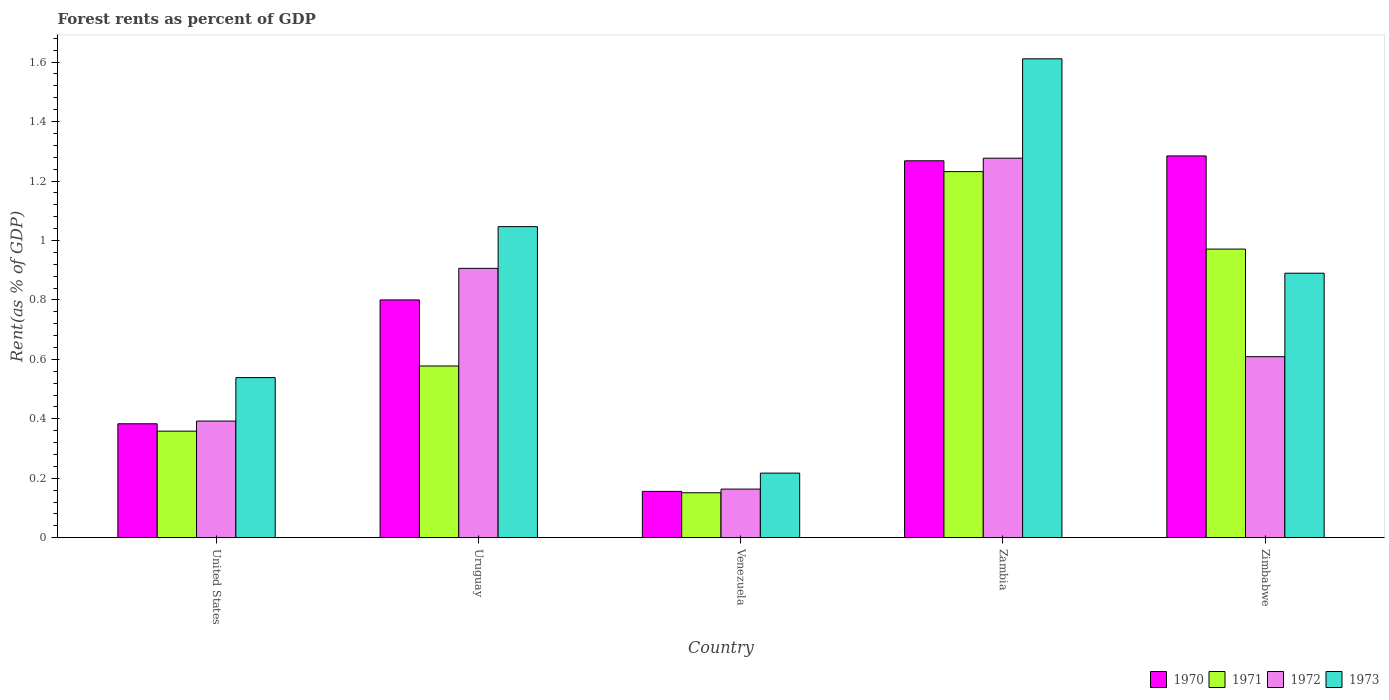How many different coloured bars are there?
Your response must be concise. 4. Are the number of bars per tick equal to the number of legend labels?
Your answer should be very brief. Yes. How many bars are there on the 5th tick from the left?
Keep it short and to the point. 4. What is the label of the 4th group of bars from the left?
Your response must be concise. Zambia. In how many cases, is the number of bars for a given country not equal to the number of legend labels?
Provide a succinct answer. 0. What is the forest rent in 1972 in Uruguay?
Make the answer very short. 0.91. Across all countries, what is the maximum forest rent in 1972?
Your response must be concise. 1.28. Across all countries, what is the minimum forest rent in 1971?
Provide a succinct answer. 0.15. In which country was the forest rent in 1970 maximum?
Ensure brevity in your answer.  Zimbabwe. In which country was the forest rent in 1970 minimum?
Provide a short and direct response. Venezuela. What is the total forest rent in 1971 in the graph?
Make the answer very short. 3.29. What is the difference between the forest rent in 1971 in Uruguay and that in Zimbabwe?
Make the answer very short. -0.39. What is the difference between the forest rent in 1972 in Zimbabwe and the forest rent in 1971 in Zambia?
Keep it short and to the point. -0.62. What is the average forest rent in 1972 per country?
Your answer should be compact. 0.67. What is the difference between the forest rent of/in 1970 and forest rent of/in 1972 in Zambia?
Offer a terse response. -0.01. What is the ratio of the forest rent in 1970 in United States to that in Uruguay?
Your answer should be compact. 0.48. What is the difference between the highest and the second highest forest rent in 1972?
Your answer should be very brief. -0.37. What is the difference between the highest and the lowest forest rent in 1971?
Keep it short and to the point. 1.08. In how many countries, is the forest rent in 1971 greater than the average forest rent in 1971 taken over all countries?
Keep it short and to the point. 2. Is the sum of the forest rent in 1973 in United States and Zimbabwe greater than the maximum forest rent in 1971 across all countries?
Your answer should be very brief. Yes. Is it the case that in every country, the sum of the forest rent in 1971 and forest rent in 1973 is greater than the sum of forest rent in 1970 and forest rent in 1972?
Provide a short and direct response. No. What does the 2nd bar from the right in Zimbabwe represents?
Make the answer very short. 1972. Where does the legend appear in the graph?
Ensure brevity in your answer.  Bottom right. How many legend labels are there?
Keep it short and to the point. 4. How are the legend labels stacked?
Provide a short and direct response. Horizontal. What is the title of the graph?
Offer a terse response. Forest rents as percent of GDP. Does "2009" appear as one of the legend labels in the graph?
Provide a succinct answer. No. What is the label or title of the X-axis?
Give a very brief answer. Country. What is the label or title of the Y-axis?
Your answer should be compact. Rent(as % of GDP). What is the Rent(as % of GDP) in 1970 in United States?
Keep it short and to the point. 0.38. What is the Rent(as % of GDP) in 1971 in United States?
Offer a terse response. 0.36. What is the Rent(as % of GDP) in 1972 in United States?
Ensure brevity in your answer.  0.39. What is the Rent(as % of GDP) in 1973 in United States?
Keep it short and to the point. 0.54. What is the Rent(as % of GDP) in 1970 in Uruguay?
Offer a very short reply. 0.8. What is the Rent(as % of GDP) in 1971 in Uruguay?
Your answer should be compact. 0.58. What is the Rent(as % of GDP) in 1972 in Uruguay?
Keep it short and to the point. 0.91. What is the Rent(as % of GDP) of 1973 in Uruguay?
Your answer should be compact. 1.05. What is the Rent(as % of GDP) in 1970 in Venezuela?
Provide a succinct answer. 0.16. What is the Rent(as % of GDP) of 1971 in Venezuela?
Provide a succinct answer. 0.15. What is the Rent(as % of GDP) in 1972 in Venezuela?
Your answer should be very brief. 0.16. What is the Rent(as % of GDP) in 1973 in Venezuela?
Keep it short and to the point. 0.22. What is the Rent(as % of GDP) in 1970 in Zambia?
Offer a very short reply. 1.27. What is the Rent(as % of GDP) of 1971 in Zambia?
Ensure brevity in your answer.  1.23. What is the Rent(as % of GDP) in 1972 in Zambia?
Make the answer very short. 1.28. What is the Rent(as % of GDP) of 1973 in Zambia?
Your answer should be compact. 1.61. What is the Rent(as % of GDP) in 1970 in Zimbabwe?
Offer a very short reply. 1.28. What is the Rent(as % of GDP) in 1971 in Zimbabwe?
Give a very brief answer. 0.97. What is the Rent(as % of GDP) of 1972 in Zimbabwe?
Your answer should be compact. 0.61. What is the Rent(as % of GDP) in 1973 in Zimbabwe?
Provide a short and direct response. 0.89. Across all countries, what is the maximum Rent(as % of GDP) of 1970?
Give a very brief answer. 1.28. Across all countries, what is the maximum Rent(as % of GDP) in 1971?
Your response must be concise. 1.23. Across all countries, what is the maximum Rent(as % of GDP) of 1972?
Offer a very short reply. 1.28. Across all countries, what is the maximum Rent(as % of GDP) of 1973?
Keep it short and to the point. 1.61. Across all countries, what is the minimum Rent(as % of GDP) of 1970?
Your answer should be very brief. 0.16. Across all countries, what is the minimum Rent(as % of GDP) in 1971?
Provide a short and direct response. 0.15. Across all countries, what is the minimum Rent(as % of GDP) of 1972?
Make the answer very short. 0.16. Across all countries, what is the minimum Rent(as % of GDP) of 1973?
Your response must be concise. 0.22. What is the total Rent(as % of GDP) of 1970 in the graph?
Your answer should be compact. 3.89. What is the total Rent(as % of GDP) in 1971 in the graph?
Your response must be concise. 3.29. What is the total Rent(as % of GDP) of 1972 in the graph?
Provide a succinct answer. 3.35. What is the total Rent(as % of GDP) of 1973 in the graph?
Your answer should be very brief. 4.3. What is the difference between the Rent(as % of GDP) in 1970 in United States and that in Uruguay?
Offer a terse response. -0.42. What is the difference between the Rent(as % of GDP) of 1971 in United States and that in Uruguay?
Your answer should be compact. -0.22. What is the difference between the Rent(as % of GDP) of 1972 in United States and that in Uruguay?
Make the answer very short. -0.51. What is the difference between the Rent(as % of GDP) of 1973 in United States and that in Uruguay?
Offer a very short reply. -0.51. What is the difference between the Rent(as % of GDP) of 1970 in United States and that in Venezuela?
Your response must be concise. 0.23. What is the difference between the Rent(as % of GDP) of 1971 in United States and that in Venezuela?
Offer a terse response. 0.21. What is the difference between the Rent(as % of GDP) in 1972 in United States and that in Venezuela?
Provide a succinct answer. 0.23. What is the difference between the Rent(as % of GDP) of 1973 in United States and that in Venezuela?
Keep it short and to the point. 0.32. What is the difference between the Rent(as % of GDP) of 1970 in United States and that in Zambia?
Make the answer very short. -0.88. What is the difference between the Rent(as % of GDP) in 1971 in United States and that in Zambia?
Your response must be concise. -0.87. What is the difference between the Rent(as % of GDP) in 1972 in United States and that in Zambia?
Give a very brief answer. -0.88. What is the difference between the Rent(as % of GDP) in 1973 in United States and that in Zambia?
Ensure brevity in your answer.  -1.07. What is the difference between the Rent(as % of GDP) of 1970 in United States and that in Zimbabwe?
Offer a terse response. -0.9. What is the difference between the Rent(as % of GDP) in 1971 in United States and that in Zimbabwe?
Give a very brief answer. -0.61. What is the difference between the Rent(as % of GDP) of 1972 in United States and that in Zimbabwe?
Provide a succinct answer. -0.22. What is the difference between the Rent(as % of GDP) in 1973 in United States and that in Zimbabwe?
Your response must be concise. -0.35. What is the difference between the Rent(as % of GDP) in 1970 in Uruguay and that in Venezuela?
Your response must be concise. 0.64. What is the difference between the Rent(as % of GDP) in 1971 in Uruguay and that in Venezuela?
Make the answer very short. 0.43. What is the difference between the Rent(as % of GDP) of 1972 in Uruguay and that in Venezuela?
Offer a very short reply. 0.74. What is the difference between the Rent(as % of GDP) in 1973 in Uruguay and that in Venezuela?
Offer a very short reply. 0.83. What is the difference between the Rent(as % of GDP) of 1970 in Uruguay and that in Zambia?
Your response must be concise. -0.47. What is the difference between the Rent(as % of GDP) of 1971 in Uruguay and that in Zambia?
Keep it short and to the point. -0.65. What is the difference between the Rent(as % of GDP) of 1972 in Uruguay and that in Zambia?
Give a very brief answer. -0.37. What is the difference between the Rent(as % of GDP) in 1973 in Uruguay and that in Zambia?
Your answer should be very brief. -0.56. What is the difference between the Rent(as % of GDP) of 1970 in Uruguay and that in Zimbabwe?
Keep it short and to the point. -0.48. What is the difference between the Rent(as % of GDP) of 1971 in Uruguay and that in Zimbabwe?
Keep it short and to the point. -0.39. What is the difference between the Rent(as % of GDP) of 1972 in Uruguay and that in Zimbabwe?
Provide a short and direct response. 0.3. What is the difference between the Rent(as % of GDP) of 1973 in Uruguay and that in Zimbabwe?
Ensure brevity in your answer.  0.16. What is the difference between the Rent(as % of GDP) in 1970 in Venezuela and that in Zambia?
Offer a terse response. -1.11. What is the difference between the Rent(as % of GDP) of 1971 in Venezuela and that in Zambia?
Offer a terse response. -1.08. What is the difference between the Rent(as % of GDP) in 1972 in Venezuela and that in Zambia?
Provide a short and direct response. -1.11. What is the difference between the Rent(as % of GDP) of 1973 in Venezuela and that in Zambia?
Your answer should be compact. -1.39. What is the difference between the Rent(as % of GDP) in 1970 in Venezuela and that in Zimbabwe?
Provide a succinct answer. -1.13. What is the difference between the Rent(as % of GDP) in 1971 in Venezuela and that in Zimbabwe?
Give a very brief answer. -0.82. What is the difference between the Rent(as % of GDP) in 1972 in Venezuela and that in Zimbabwe?
Offer a very short reply. -0.45. What is the difference between the Rent(as % of GDP) in 1973 in Venezuela and that in Zimbabwe?
Ensure brevity in your answer.  -0.67. What is the difference between the Rent(as % of GDP) in 1970 in Zambia and that in Zimbabwe?
Ensure brevity in your answer.  -0.02. What is the difference between the Rent(as % of GDP) of 1971 in Zambia and that in Zimbabwe?
Your answer should be very brief. 0.26. What is the difference between the Rent(as % of GDP) of 1972 in Zambia and that in Zimbabwe?
Provide a short and direct response. 0.67. What is the difference between the Rent(as % of GDP) in 1973 in Zambia and that in Zimbabwe?
Your response must be concise. 0.72. What is the difference between the Rent(as % of GDP) in 1970 in United States and the Rent(as % of GDP) in 1971 in Uruguay?
Offer a terse response. -0.19. What is the difference between the Rent(as % of GDP) in 1970 in United States and the Rent(as % of GDP) in 1972 in Uruguay?
Your answer should be very brief. -0.52. What is the difference between the Rent(as % of GDP) in 1970 in United States and the Rent(as % of GDP) in 1973 in Uruguay?
Give a very brief answer. -0.66. What is the difference between the Rent(as % of GDP) in 1971 in United States and the Rent(as % of GDP) in 1972 in Uruguay?
Provide a short and direct response. -0.55. What is the difference between the Rent(as % of GDP) in 1971 in United States and the Rent(as % of GDP) in 1973 in Uruguay?
Ensure brevity in your answer.  -0.69. What is the difference between the Rent(as % of GDP) of 1972 in United States and the Rent(as % of GDP) of 1973 in Uruguay?
Offer a terse response. -0.65. What is the difference between the Rent(as % of GDP) in 1970 in United States and the Rent(as % of GDP) in 1971 in Venezuela?
Ensure brevity in your answer.  0.23. What is the difference between the Rent(as % of GDP) in 1970 in United States and the Rent(as % of GDP) in 1972 in Venezuela?
Your answer should be compact. 0.22. What is the difference between the Rent(as % of GDP) in 1970 in United States and the Rent(as % of GDP) in 1973 in Venezuela?
Provide a succinct answer. 0.17. What is the difference between the Rent(as % of GDP) of 1971 in United States and the Rent(as % of GDP) of 1972 in Venezuela?
Your response must be concise. 0.2. What is the difference between the Rent(as % of GDP) in 1971 in United States and the Rent(as % of GDP) in 1973 in Venezuela?
Offer a terse response. 0.14. What is the difference between the Rent(as % of GDP) of 1972 in United States and the Rent(as % of GDP) of 1973 in Venezuela?
Your response must be concise. 0.18. What is the difference between the Rent(as % of GDP) of 1970 in United States and the Rent(as % of GDP) of 1971 in Zambia?
Provide a short and direct response. -0.85. What is the difference between the Rent(as % of GDP) in 1970 in United States and the Rent(as % of GDP) in 1972 in Zambia?
Your response must be concise. -0.89. What is the difference between the Rent(as % of GDP) in 1970 in United States and the Rent(as % of GDP) in 1973 in Zambia?
Your answer should be very brief. -1.23. What is the difference between the Rent(as % of GDP) in 1971 in United States and the Rent(as % of GDP) in 1972 in Zambia?
Offer a terse response. -0.92. What is the difference between the Rent(as % of GDP) in 1971 in United States and the Rent(as % of GDP) in 1973 in Zambia?
Give a very brief answer. -1.25. What is the difference between the Rent(as % of GDP) in 1972 in United States and the Rent(as % of GDP) in 1973 in Zambia?
Offer a very short reply. -1.22. What is the difference between the Rent(as % of GDP) of 1970 in United States and the Rent(as % of GDP) of 1971 in Zimbabwe?
Offer a terse response. -0.59. What is the difference between the Rent(as % of GDP) in 1970 in United States and the Rent(as % of GDP) in 1972 in Zimbabwe?
Make the answer very short. -0.23. What is the difference between the Rent(as % of GDP) of 1970 in United States and the Rent(as % of GDP) of 1973 in Zimbabwe?
Keep it short and to the point. -0.51. What is the difference between the Rent(as % of GDP) in 1971 in United States and the Rent(as % of GDP) in 1972 in Zimbabwe?
Your response must be concise. -0.25. What is the difference between the Rent(as % of GDP) in 1971 in United States and the Rent(as % of GDP) in 1973 in Zimbabwe?
Your answer should be compact. -0.53. What is the difference between the Rent(as % of GDP) of 1972 in United States and the Rent(as % of GDP) of 1973 in Zimbabwe?
Offer a terse response. -0.5. What is the difference between the Rent(as % of GDP) of 1970 in Uruguay and the Rent(as % of GDP) of 1971 in Venezuela?
Offer a very short reply. 0.65. What is the difference between the Rent(as % of GDP) in 1970 in Uruguay and the Rent(as % of GDP) in 1972 in Venezuela?
Your response must be concise. 0.64. What is the difference between the Rent(as % of GDP) of 1970 in Uruguay and the Rent(as % of GDP) of 1973 in Venezuela?
Your response must be concise. 0.58. What is the difference between the Rent(as % of GDP) in 1971 in Uruguay and the Rent(as % of GDP) in 1972 in Venezuela?
Your answer should be very brief. 0.41. What is the difference between the Rent(as % of GDP) in 1971 in Uruguay and the Rent(as % of GDP) in 1973 in Venezuela?
Provide a short and direct response. 0.36. What is the difference between the Rent(as % of GDP) of 1972 in Uruguay and the Rent(as % of GDP) of 1973 in Venezuela?
Offer a terse response. 0.69. What is the difference between the Rent(as % of GDP) of 1970 in Uruguay and the Rent(as % of GDP) of 1971 in Zambia?
Make the answer very short. -0.43. What is the difference between the Rent(as % of GDP) in 1970 in Uruguay and the Rent(as % of GDP) in 1972 in Zambia?
Offer a very short reply. -0.48. What is the difference between the Rent(as % of GDP) in 1970 in Uruguay and the Rent(as % of GDP) in 1973 in Zambia?
Offer a very short reply. -0.81. What is the difference between the Rent(as % of GDP) of 1971 in Uruguay and the Rent(as % of GDP) of 1972 in Zambia?
Give a very brief answer. -0.7. What is the difference between the Rent(as % of GDP) of 1971 in Uruguay and the Rent(as % of GDP) of 1973 in Zambia?
Ensure brevity in your answer.  -1.03. What is the difference between the Rent(as % of GDP) in 1972 in Uruguay and the Rent(as % of GDP) in 1973 in Zambia?
Offer a terse response. -0.7. What is the difference between the Rent(as % of GDP) in 1970 in Uruguay and the Rent(as % of GDP) in 1971 in Zimbabwe?
Your answer should be compact. -0.17. What is the difference between the Rent(as % of GDP) of 1970 in Uruguay and the Rent(as % of GDP) of 1972 in Zimbabwe?
Your answer should be compact. 0.19. What is the difference between the Rent(as % of GDP) of 1970 in Uruguay and the Rent(as % of GDP) of 1973 in Zimbabwe?
Make the answer very short. -0.09. What is the difference between the Rent(as % of GDP) in 1971 in Uruguay and the Rent(as % of GDP) in 1972 in Zimbabwe?
Provide a short and direct response. -0.03. What is the difference between the Rent(as % of GDP) in 1971 in Uruguay and the Rent(as % of GDP) in 1973 in Zimbabwe?
Offer a very short reply. -0.31. What is the difference between the Rent(as % of GDP) of 1972 in Uruguay and the Rent(as % of GDP) of 1973 in Zimbabwe?
Give a very brief answer. 0.02. What is the difference between the Rent(as % of GDP) in 1970 in Venezuela and the Rent(as % of GDP) in 1971 in Zambia?
Offer a terse response. -1.08. What is the difference between the Rent(as % of GDP) in 1970 in Venezuela and the Rent(as % of GDP) in 1972 in Zambia?
Ensure brevity in your answer.  -1.12. What is the difference between the Rent(as % of GDP) in 1970 in Venezuela and the Rent(as % of GDP) in 1973 in Zambia?
Offer a very short reply. -1.46. What is the difference between the Rent(as % of GDP) in 1971 in Venezuela and the Rent(as % of GDP) in 1972 in Zambia?
Make the answer very short. -1.13. What is the difference between the Rent(as % of GDP) in 1971 in Venezuela and the Rent(as % of GDP) in 1973 in Zambia?
Your answer should be compact. -1.46. What is the difference between the Rent(as % of GDP) of 1972 in Venezuela and the Rent(as % of GDP) of 1973 in Zambia?
Your answer should be compact. -1.45. What is the difference between the Rent(as % of GDP) of 1970 in Venezuela and the Rent(as % of GDP) of 1971 in Zimbabwe?
Give a very brief answer. -0.82. What is the difference between the Rent(as % of GDP) in 1970 in Venezuela and the Rent(as % of GDP) in 1972 in Zimbabwe?
Give a very brief answer. -0.45. What is the difference between the Rent(as % of GDP) of 1970 in Venezuela and the Rent(as % of GDP) of 1973 in Zimbabwe?
Give a very brief answer. -0.73. What is the difference between the Rent(as % of GDP) of 1971 in Venezuela and the Rent(as % of GDP) of 1972 in Zimbabwe?
Your answer should be very brief. -0.46. What is the difference between the Rent(as % of GDP) of 1971 in Venezuela and the Rent(as % of GDP) of 1973 in Zimbabwe?
Offer a very short reply. -0.74. What is the difference between the Rent(as % of GDP) in 1972 in Venezuela and the Rent(as % of GDP) in 1973 in Zimbabwe?
Ensure brevity in your answer.  -0.73. What is the difference between the Rent(as % of GDP) in 1970 in Zambia and the Rent(as % of GDP) in 1971 in Zimbabwe?
Your response must be concise. 0.3. What is the difference between the Rent(as % of GDP) in 1970 in Zambia and the Rent(as % of GDP) in 1972 in Zimbabwe?
Make the answer very short. 0.66. What is the difference between the Rent(as % of GDP) of 1970 in Zambia and the Rent(as % of GDP) of 1973 in Zimbabwe?
Make the answer very short. 0.38. What is the difference between the Rent(as % of GDP) in 1971 in Zambia and the Rent(as % of GDP) in 1972 in Zimbabwe?
Keep it short and to the point. 0.62. What is the difference between the Rent(as % of GDP) of 1971 in Zambia and the Rent(as % of GDP) of 1973 in Zimbabwe?
Your answer should be compact. 0.34. What is the difference between the Rent(as % of GDP) of 1972 in Zambia and the Rent(as % of GDP) of 1973 in Zimbabwe?
Give a very brief answer. 0.39. What is the average Rent(as % of GDP) of 1970 per country?
Ensure brevity in your answer.  0.78. What is the average Rent(as % of GDP) of 1971 per country?
Your answer should be compact. 0.66. What is the average Rent(as % of GDP) in 1972 per country?
Make the answer very short. 0.67. What is the average Rent(as % of GDP) in 1973 per country?
Provide a succinct answer. 0.86. What is the difference between the Rent(as % of GDP) of 1970 and Rent(as % of GDP) of 1971 in United States?
Offer a very short reply. 0.02. What is the difference between the Rent(as % of GDP) in 1970 and Rent(as % of GDP) in 1972 in United States?
Your answer should be compact. -0.01. What is the difference between the Rent(as % of GDP) of 1970 and Rent(as % of GDP) of 1973 in United States?
Give a very brief answer. -0.16. What is the difference between the Rent(as % of GDP) in 1971 and Rent(as % of GDP) in 1972 in United States?
Ensure brevity in your answer.  -0.03. What is the difference between the Rent(as % of GDP) of 1971 and Rent(as % of GDP) of 1973 in United States?
Your answer should be very brief. -0.18. What is the difference between the Rent(as % of GDP) of 1972 and Rent(as % of GDP) of 1973 in United States?
Give a very brief answer. -0.15. What is the difference between the Rent(as % of GDP) in 1970 and Rent(as % of GDP) in 1971 in Uruguay?
Provide a succinct answer. 0.22. What is the difference between the Rent(as % of GDP) of 1970 and Rent(as % of GDP) of 1972 in Uruguay?
Your answer should be compact. -0.11. What is the difference between the Rent(as % of GDP) in 1970 and Rent(as % of GDP) in 1973 in Uruguay?
Make the answer very short. -0.25. What is the difference between the Rent(as % of GDP) in 1971 and Rent(as % of GDP) in 1972 in Uruguay?
Ensure brevity in your answer.  -0.33. What is the difference between the Rent(as % of GDP) in 1971 and Rent(as % of GDP) in 1973 in Uruguay?
Your answer should be very brief. -0.47. What is the difference between the Rent(as % of GDP) of 1972 and Rent(as % of GDP) of 1973 in Uruguay?
Your response must be concise. -0.14. What is the difference between the Rent(as % of GDP) in 1970 and Rent(as % of GDP) in 1971 in Venezuela?
Provide a short and direct response. 0. What is the difference between the Rent(as % of GDP) of 1970 and Rent(as % of GDP) of 1972 in Venezuela?
Your answer should be very brief. -0.01. What is the difference between the Rent(as % of GDP) in 1970 and Rent(as % of GDP) in 1973 in Venezuela?
Keep it short and to the point. -0.06. What is the difference between the Rent(as % of GDP) of 1971 and Rent(as % of GDP) of 1972 in Venezuela?
Keep it short and to the point. -0.01. What is the difference between the Rent(as % of GDP) of 1971 and Rent(as % of GDP) of 1973 in Venezuela?
Your response must be concise. -0.07. What is the difference between the Rent(as % of GDP) in 1972 and Rent(as % of GDP) in 1973 in Venezuela?
Ensure brevity in your answer.  -0.05. What is the difference between the Rent(as % of GDP) in 1970 and Rent(as % of GDP) in 1971 in Zambia?
Provide a succinct answer. 0.04. What is the difference between the Rent(as % of GDP) of 1970 and Rent(as % of GDP) of 1972 in Zambia?
Provide a succinct answer. -0.01. What is the difference between the Rent(as % of GDP) of 1970 and Rent(as % of GDP) of 1973 in Zambia?
Provide a short and direct response. -0.34. What is the difference between the Rent(as % of GDP) in 1971 and Rent(as % of GDP) in 1972 in Zambia?
Keep it short and to the point. -0.05. What is the difference between the Rent(as % of GDP) of 1971 and Rent(as % of GDP) of 1973 in Zambia?
Your answer should be compact. -0.38. What is the difference between the Rent(as % of GDP) in 1972 and Rent(as % of GDP) in 1973 in Zambia?
Provide a succinct answer. -0.33. What is the difference between the Rent(as % of GDP) of 1970 and Rent(as % of GDP) of 1971 in Zimbabwe?
Make the answer very short. 0.31. What is the difference between the Rent(as % of GDP) in 1970 and Rent(as % of GDP) in 1972 in Zimbabwe?
Ensure brevity in your answer.  0.68. What is the difference between the Rent(as % of GDP) in 1970 and Rent(as % of GDP) in 1973 in Zimbabwe?
Make the answer very short. 0.39. What is the difference between the Rent(as % of GDP) in 1971 and Rent(as % of GDP) in 1972 in Zimbabwe?
Offer a very short reply. 0.36. What is the difference between the Rent(as % of GDP) of 1971 and Rent(as % of GDP) of 1973 in Zimbabwe?
Give a very brief answer. 0.08. What is the difference between the Rent(as % of GDP) in 1972 and Rent(as % of GDP) in 1973 in Zimbabwe?
Provide a short and direct response. -0.28. What is the ratio of the Rent(as % of GDP) in 1970 in United States to that in Uruguay?
Provide a succinct answer. 0.48. What is the ratio of the Rent(as % of GDP) in 1971 in United States to that in Uruguay?
Make the answer very short. 0.62. What is the ratio of the Rent(as % of GDP) of 1972 in United States to that in Uruguay?
Offer a very short reply. 0.43. What is the ratio of the Rent(as % of GDP) in 1973 in United States to that in Uruguay?
Ensure brevity in your answer.  0.51. What is the ratio of the Rent(as % of GDP) in 1970 in United States to that in Venezuela?
Ensure brevity in your answer.  2.46. What is the ratio of the Rent(as % of GDP) in 1971 in United States to that in Venezuela?
Provide a succinct answer. 2.37. What is the ratio of the Rent(as % of GDP) in 1972 in United States to that in Venezuela?
Your answer should be compact. 2.4. What is the ratio of the Rent(as % of GDP) of 1973 in United States to that in Venezuela?
Provide a succinct answer. 2.48. What is the ratio of the Rent(as % of GDP) in 1970 in United States to that in Zambia?
Offer a very short reply. 0.3. What is the ratio of the Rent(as % of GDP) of 1971 in United States to that in Zambia?
Offer a very short reply. 0.29. What is the ratio of the Rent(as % of GDP) in 1972 in United States to that in Zambia?
Your response must be concise. 0.31. What is the ratio of the Rent(as % of GDP) of 1973 in United States to that in Zambia?
Your response must be concise. 0.33. What is the ratio of the Rent(as % of GDP) in 1970 in United States to that in Zimbabwe?
Provide a short and direct response. 0.3. What is the ratio of the Rent(as % of GDP) of 1971 in United States to that in Zimbabwe?
Give a very brief answer. 0.37. What is the ratio of the Rent(as % of GDP) of 1972 in United States to that in Zimbabwe?
Provide a succinct answer. 0.64. What is the ratio of the Rent(as % of GDP) of 1973 in United States to that in Zimbabwe?
Keep it short and to the point. 0.61. What is the ratio of the Rent(as % of GDP) of 1970 in Uruguay to that in Venezuela?
Your answer should be compact. 5.13. What is the ratio of the Rent(as % of GDP) in 1971 in Uruguay to that in Venezuela?
Your response must be concise. 3.82. What is the ratio of the Rent(as % of GDP) in 1972 in Uruguay to that in Venezuela?
Your answer should be very brief. 5.54. What is the ratio of the Rent(as % of GDP) in 1973 in Uruguay to that in Venezuela?
Your answer should be compact. 4.82. What is the ratio of the Rent(as % of GDP) in 1970 in Uruguay to that in Zambia?
Offer a terse response. 0.63. What is the ratio of the Rent(as % of GDP) in 1971 in Uruguay to that in Zambia?
Your answer should be very brief. 0.47. What is the ratio of the Rent(as % of GDP) of 1972 in Uruguay to that in Zambia?
Provide a short and direct response. 0.71. What is the ratio of the Rent(as % of GDP) in 1973 in Uruguay to that in Zambia?
Offer a very short reply. 0.65. What is the ratio of the Rent(as % of GDP) of 1970 in Uruguay to that in Zimbabwe?
Ensure brevity in your answer.  0.62. What is the ratio of the Rent(as % of GDP) in 1971 in Uruguay to that in Zimbabwe?
Keep it short and to the point. 0.59. What is the ratio of the Rent(as % of GDP) of 1972 in Uruguay to that in Zimbabwe?
Provide a short and direct response. 1.49. What is the ratio of the Rent(as % of GDP) of 1973 in Uruguay to that in Zimbabwe?
Your answer should be compact. 1.18. What is the ratio of the Rent(as % of GDP) in 1970 in Venezuela to that in Zambia?
Offer a terse response. 0.12. What is the ratio of the Rent(as % of GDP) of 1971 in Venezuela to that in Zambia?
Make the answer very short. 0.12. What is the ratio of the Rent(as % of GDP) in 1972 in Venezuela to that in Zambia?
Ensure brevity in your answer.  0.13. What is the ratio of the Rent(as % of GDP) in 1973 in Venezuela to that in Zambia?
Your response must be concise. 0.13. What is the ratio of the Rent(as % of GDP) of 1970 in Venezuela to that in Zimbabwe?
Provide a short and direct response. 0.12. What is the ratio of the Rent(as % of GDP) of 1971 in Venezuela to that in Zimbabwe?
Make the answer very short. 0.16. What is the ratio of the Rent(as % of GDP) in 1972 in Venezuela to that in Zimbabwe?
Provide a short and direct response. 0.27. What is the ratio of the Rent(as % of GDP) in 1973 in Venezuela to that in Zimbabwe?
Provide a short and direct response. 0.24. What is the ratio of the Rent(as % of GDP) in 1970 in Zambia to that in Zimbabwe?
Offer a terse response. 0.99. What is the ratio of the Rent(as % of GDP) in 1971 in Zambia to that in Zimbabwe?
Offer a very short reply. 1.27. What is the ratio of the Rent(as % of GDP) in 1972 in Zambia to that in Zimbabwe?
Your answer should be very brief. 2.1. What is the ratio of the Rent(as % of GDP) of 1973 in Zambia to that in Zimbabwe?
Ensure brevity in your answer.  1.81. What is the difference between the highest and the second highest Rent(as % of GDP) in 1970?
Give a very brief answer. 0.02. What is the difference between the highest and the second highest Rent(as % of GDP) of 1971?
Make the answer very short. 0.26. What is the difference between the highest and the second highest Rent(as % of GDP) of 1972?
Provide a short and direct response. 0.37. What is the difference between the highest and the second highest Rent(as % of GDP) in 1973?
Give a very brief answer. 0.56. What is the difference between the highest and the lowest Rent(as % of GDP) of 1970?
Your answer should be compact. 1.13. What is the difference between the highest and the lowest Rent(as % of GDP) of 1971?
Keep it short and to the point. 1.08. What is the difference between the highest and the lowest Rent(as % of GDP) of 1972?
Your answer should be compact. 1.11. What is the difference between the highest and the lowest Rent(as % of GDP) in 1973?
Provide a short and direct response. 1.39. 